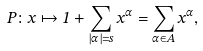Convert formula to latex. <formula><loc_0><loc_0><loc_500><loc_500>P \colon x \mapsto 1 + \sum _ { | \alpha | = s } x ^ { \alpha } = \sum _ { \alpha \in A } x ^ { \alpha } ,</formula> 